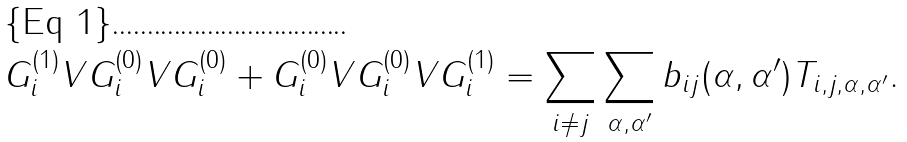Convert formula to latex. <formula><loc_0><loc_0><loc_500><loc_500>G _ { i } ^ { ( 1 ) } V G _ { i } ^ { ( 0 ) } V G _ { i } ^ { ( 0 ) } + G _ { i } ^ { ( 0 ) } V G _ { i } ^ { ( 0 ) } V G _ { i } ^ { ( 1 ) } = \sum _ { i \neq j } \sum _ { \alpha , \alpha ^ { \prime } } b _ { i j } ( \alpha , \alpha ^ { \prime } ) T _ { i , j , \alpha , \alpha ^ { \prime } } .</formula> 